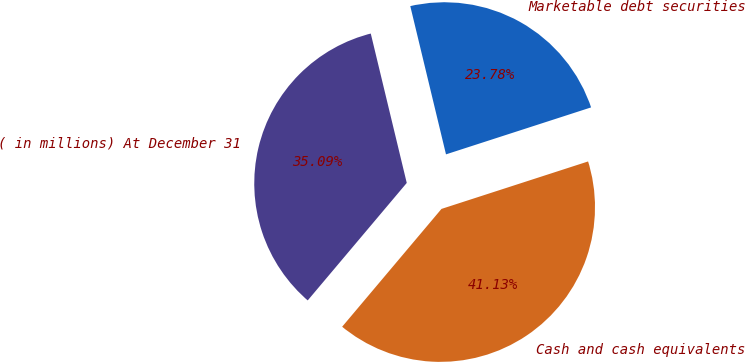<chart> <loc_0><loc_0><loc_500><loc_500><pie_chart><fcel>( in millions) At December 31<fcel>Cash and cash equivalents<fcel>Marketable debt securities<nl><fcel>35.09%<fcel>41.13%<fcel>23.78%<nl></chart> 